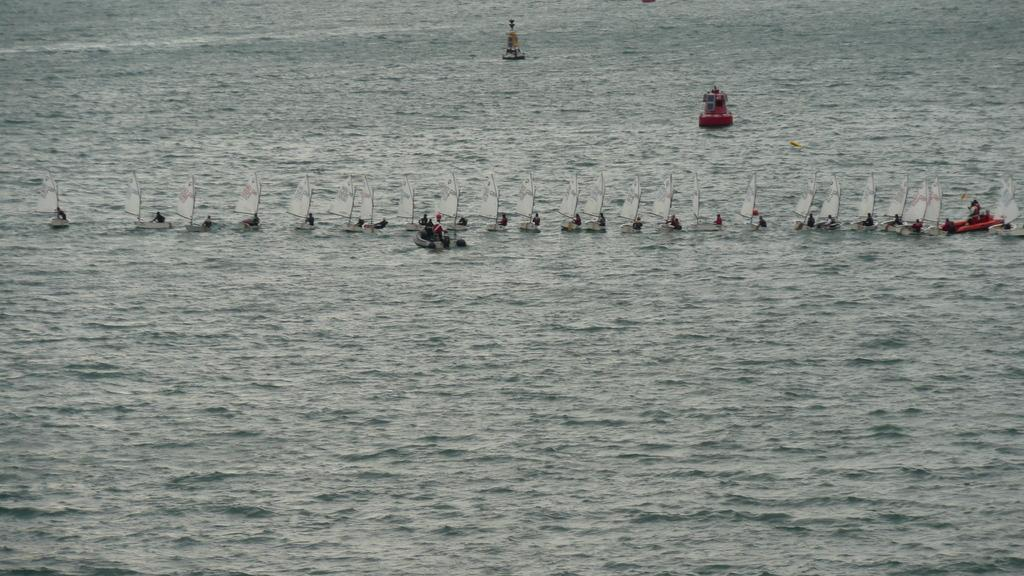Who is present in the image? There are people in the image. What are the people doing in the image? The people are sailing a boat. Where is the boat located in the image? The boat is on the water. What type of doll is sitting on the scissors in the image? There is no doll or scissors present in the image; it features people sailing a boat on the water. 